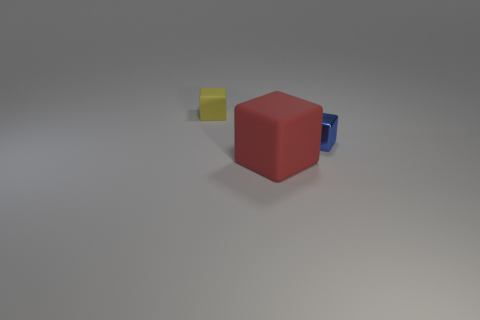Subtract all matte cubes. How many cubes are left? 1 Add 1 small blocks. How many objects exist? 4 Subtract all blue cubes. How many cubes are left? 2 Subtract all yellow cubes. Subtract all gray cylinders. How many cubes are left? 2 Add 2 yellow rubber things. How many yellow rubber things are left? 3 Add 1 big cubes. How many big cubes exist? 2 Subtract 0 purple spheres. How many objects are left? 3 Subtract 1 blocks. How many blocks are left? 2 Subtract all big yellow rubber blocks. Subtract all large red objects. How many objects are left? 2 